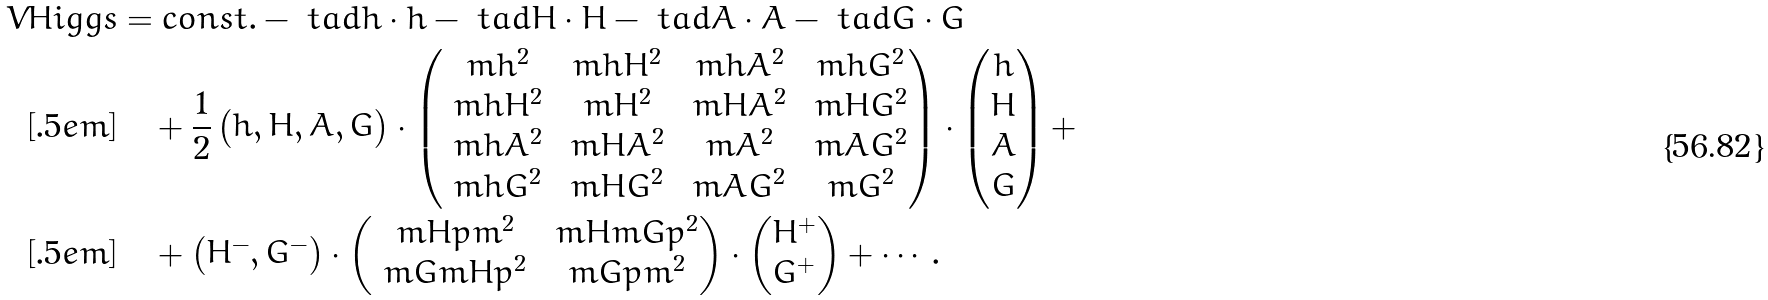Convert formula to latex. <formula><loc_0><loc_0><loc_500><loc_500>\ V H i g g s & = c o n s t . - \ t a d h \cdot h - \ t a d H \cdot H - \ t a d A \cdot A - \ t a d G \cdot G \\ [ . 5 e m ] & \quad + \frac { 1 } { 2 } \begin{pmatrix} h , H , A , G \end{pmatrix} \cdot \begin{pmatrix} \ m h ^ { 2 } & \ m h H ^ { 2 } & \ m h A ^ { 2 } & \ m h G ^ { 2 } \\ \ m h H ^ { 2 } & \ m H ^ { 2 } & \ m H A ^ { 2 } & \ m H G ^ { 2 } \\ \ m h A ^ { 2 } & \ m H A ^ { 2 } & \ m A ^ { 2 } & \ m A G ^ { 2 } \\ \ m h G ^ { 2 } & \ m H G ^ { 2 } & \ m A G ^ { 2 } & \ m G ^ { 2 } \end{pmatrix} \cdot \begin{pmatrix} h \\ H \\ A \\ G \end{pmatrix} + \\ [ . 5 e m ] & \quad + \begin{pmatrix} H ^ { - } , G ^ { - } \end{pmatrix} \cdot \begin{pmatrix} \ m H p m ^ { 2 } & \ m H m G p ^ { 2 } \\ \ m G m H p ^ { 2 } & \ m G p m ^ { 2 } \end{pmatrix} \cdot \begin{pmatrix} H ^ { + } \\ G ^ { + } \end{pmatrix} + \cdots .</formula> 